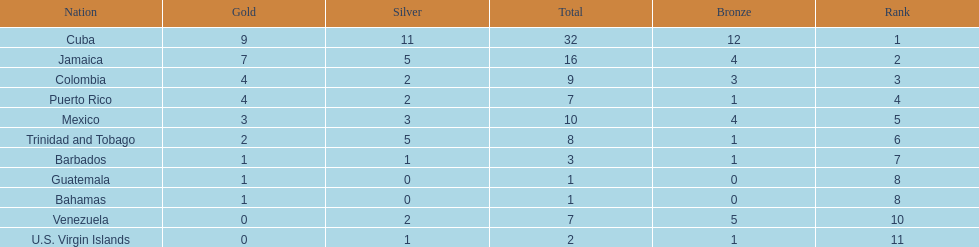Only team to have more than 30 medals Cuba. 